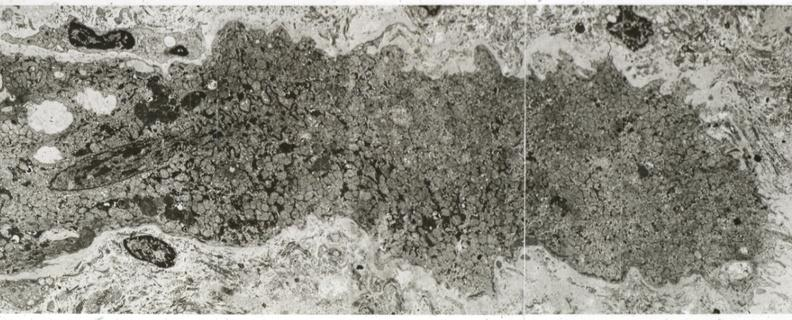where is this area in the body?
Answer the question using a single word or phrase. Heart 